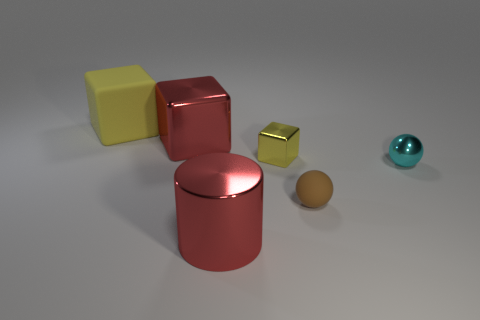Add 1 cyan spheres. How many objects exist? 7 Subtract all cylinders. How many objects are left? 5 Add 5 red cylinders. How many red cylinders are left? 6 Add 3 small purple metal cubes. How many small purple metal cubes exist? 3 Subtract 0 green balls. How many objects are left? 6 Subtract all small metallic spheres. Subtract all cubes. How many objects are left? 2 